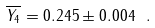<formula> <loc_0><loc_0><loc_500><loc_500>\overline { Y _ { 4 } } = 0 . 2 4 5 \pm 0 . 0 0 4 \ .</formula> 